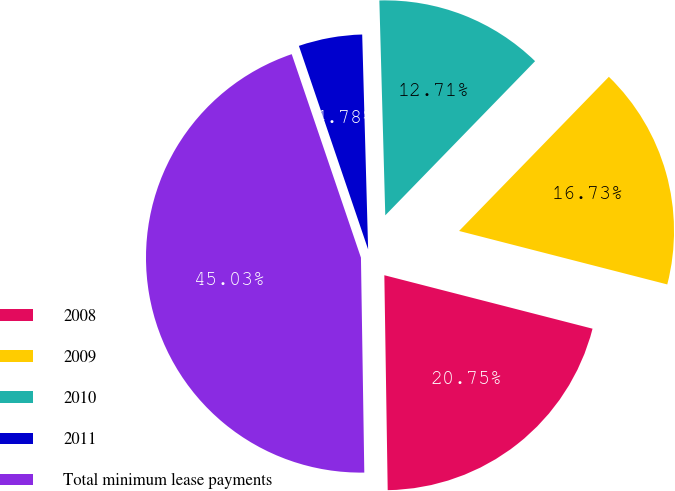Convert chart to OTSL. <chart><loc_0><loc_0><loc_500><loc_500><pie_chart><fcel>2008<fcel>2009<fcel>2010<fcel>2011<fcel>Total minimum lease payments<nl><fcel>20.75%<fcel>16.73%<fcel>12.71%<fcel>4.78%<fcel>45.03%<nl></chart> 